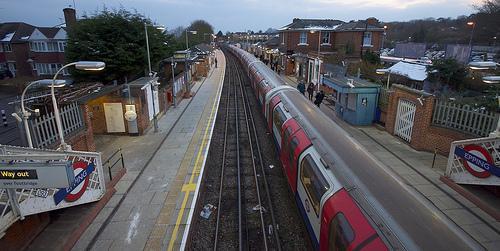How many trains?
Give a very brief answer. 1. How many people are sitting in the image?
Give a very brief answer. 0. 